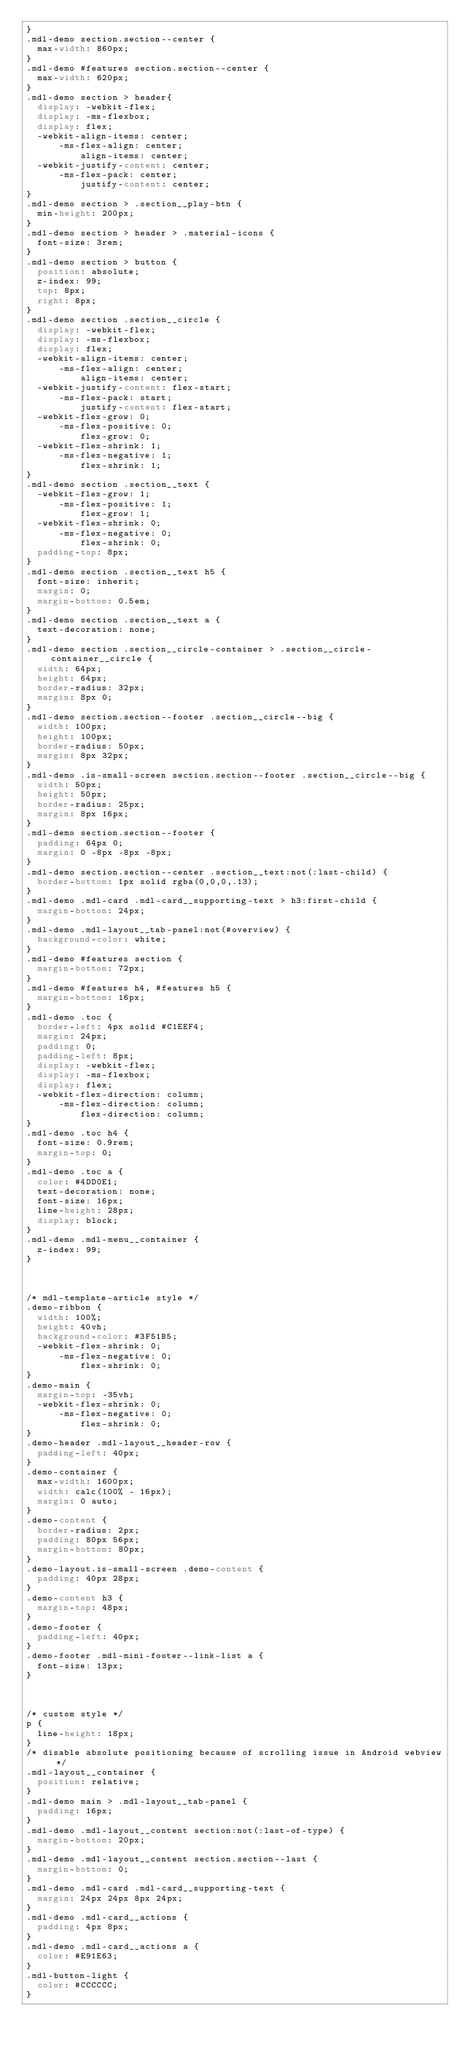<code> <loc_0><loc_0><loc_500><loc_500><_CSS_>}
.mdl-demo section.section--center {
  max-width: 860px;
}
.mdl-demo #features section.section--center {
  max-width: 620px;
}
.mdl-demo section > header{
  display: -webkit-flex;
  display: -ms-flexbox;
  display: flex;
  -webkit-align-items: center;
      -ms-flex-align: center;
          align-items: center;
  -webkit-justify-content: center;
      -ms-flex-pack: center;
          justify-content: center;
}
.mdl-demo section > .section__play-btn {
  min-height: 200px;
}
.mdl-demo section > header > .material-icons {
  font-size: 3rem;
}
.mdl-demo section > button {
  position: absolute;
  z-index: 99;
  top: 8px;
  right: 8px;
}
.mdl-demo section .section__circle {
  display: -webkit-flex;
  display: -ms-flexbox;
  display: flex;
  -webkit-align-items: center;
      -ms-flex-align: center;
          align-items: center;
  -webkit-justify-content: flex-start;
      -ms-flex-pack: start;
          justify-content: flex-start;
  -webkit-flex-grow: 0;
      -ms-flex-positive: 0;
          flex-grow: 0;
  -webkit-flex-shrink: 1;
      -ms-flex-negative: 1;
          flex-shrink: 1;
}
.mdl-demo section .section__text {
  -webkit-flex-grow: 1;
      -ms-flex-positive: 1;
          flex-grow: 1;
  -webkit-flex-shrink: 0;
      -ms-flex-negative: 0;
          flex-shrink: 0;
  padding-top: 8px;
}
.mdl-demo section .section__text h5 {
  font-size: inherit;
  margin: 0;
  margin-bottom: 0.5em;
}
.mdl-demo section .section__text a {
  text-decoration: none;
}
.mdl-demo section .section__circle-container > .section__circle-container__circle {
  width: 64px;
  height: 64px;
  border-radius: 32px;
  margin: 8px 0;
}
.mdl-demo section.section--footer .section__circle--big {
  width: 100px;
  height: 100px;
  border-radius: 50px;
  margin: 8px 32px;
}
.mdl-demo .is-small-screen section.section--footer .section__circle--big {
  width: 50px;
  height: 50px;
  border-radius: 25px;
  margin: 8px 16px;
}
.mdl-demo section.section--footer {
  padding: 64px 0;
  margin: 0 -8px -8px -8px;
}
.mdl-demo section.section--center .section__text:not(:last-child) {
  border-bottom: 1px solid rgba(0,0,0,.13);
}
.mdl-demo .mdl-card .mdl-card__supporting-text > h3:first-child {
  margin-bottom: 24px;
}
.mdl-demo .mdl-layout__tab-panel:not(#overview) {
  background-color: white;
}
.mdl-demo #features section {
  margin-bottom: 72px;
}
.mdl-demo #features h4, #features h5 {
  margin-bottom: 16px;
}
.mdl-demo .toc {
  border-left: 4px solid #C1EEF4;
  margin: 24px;
  padding: 0;
  padding-left: 8px;
  display: -webkit-flex;
  display: -ms-flexbox;
  display: flex;
  -webkit-flex-direction: column;
      -ms-flex-direction: column;
          flex-direction: column;
}
.mdl-demo .toc h4 {
  font-size: 0.9rem;
  margin-top: 0;
}
.mdl-demo .toc a {
  color: #4DD0E1;
  text-decoration: none;
  font-size: 16px;
  line-height: 28px;
  display: block;
}
.mdl-demo .mdl-menu__container {
  z-index: 99;
}



/* mdl-template-article style */
.demo-ribbon {
  width: 100%;
  height: 40vh;
  background-color: #3F51B5;
  -webkit-flex-shrink: 0;
      -ms-flex-negative: 0;
          flex-shrink: 0;
}
.demo-main {
  margin-top: -35vh;
  -webkit-flex-shrink: 0;
      -ms-flex-negative: 0;
          flex-shrink: 0;
}
.demo-header .mdl-layout__header-row {
  padding-left: 40px;
}
.demo-container {
  max-width: 1600px;
  width: calc(100% - 16px);
  margin: 0 auto;
}
.demo-content {
  border-radius: 2px;
  padding: 80px 56px;
  margin-bottom: 80px;
}
.demo-layout.is-small-screen .demo-content {
  padding: 40px 28px;
}
.demo-content h3 {
  margin-top: 48px;
}
.demo-footer {
  padding-left: 40px;
}
.demo-footer .mdl-mini-footer--link-list a {
  font-size: 13px;
}



/* custom style */
p {
  line-height: 18px;
}
/* disable absolute positioning because of scrolling issue in Android webview */
.mdl-layout__container {
  position: relative;
}
.mdl-demo main > .mdl-layout__tab-panel {
  padding: 16px;
}
.mdl-demo .mdl-layout__content section:not(:last-of-type) {
  margin-bottom: 20px;
}
.mdl-demo .mdl-layout__content section.section--last {
  margin-bottom: 0;
}
.mdl-demo .mdl-card .mdl-card__supporting-text {
  margin: 24px 24px 8px 24px;
}
.mdl-demo .mdl-card__actions {
  padding: 4px 8px;
}
.mdl-demo .mdl-card__actions a {
  color: #E91E63;
}
.mdl-button-light {
  color: #CCCCCC;
}</code> 